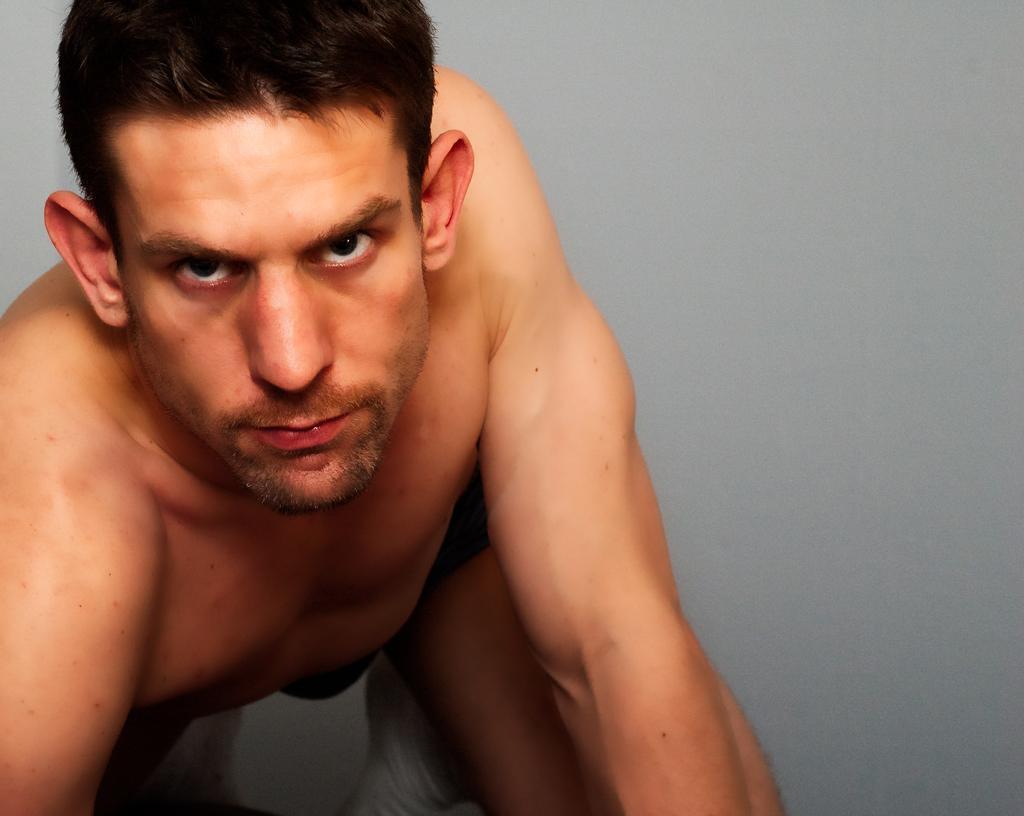Can you describe this image briefly? In this image I can see the person and there is an ash color background. 